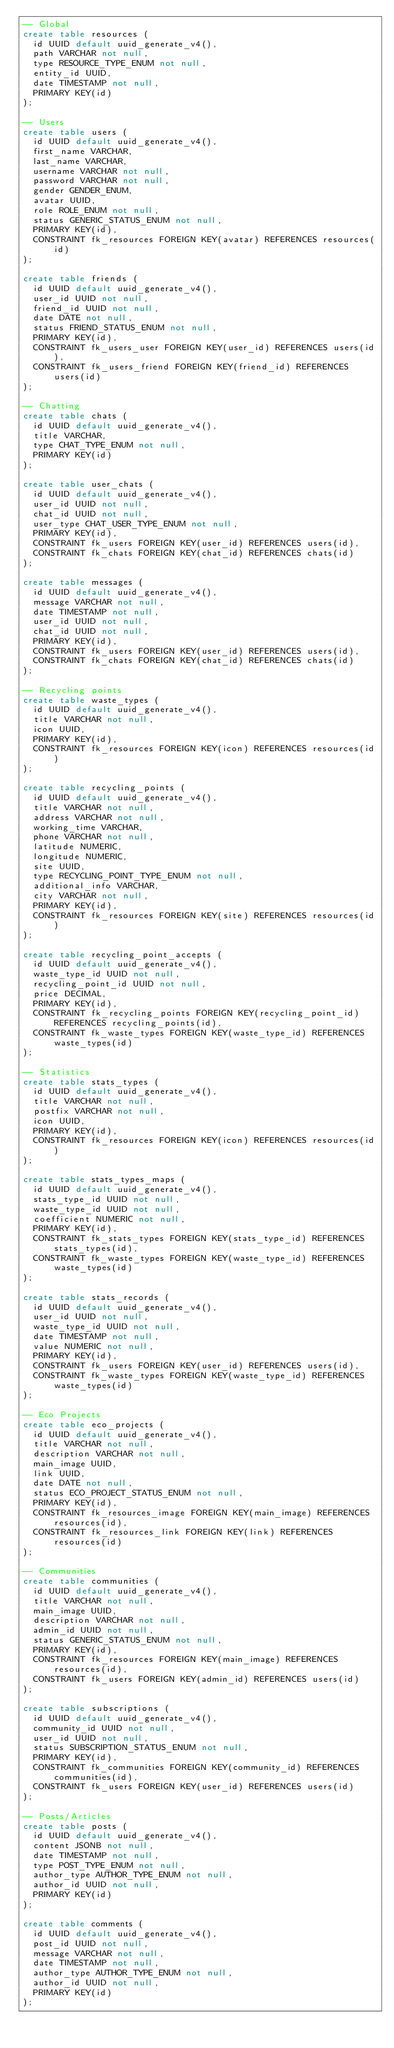<code> <loc_0><loc_0><loc_500><loc_500><_SQL_>-- Global
create table resources (
  id UUID default uuid_generate_v4(),
  path VARCHAR not null,
  type RESOURCE_TYPE_ENUM not null,
  entity_id UUID,
  date TIMESTAMP not null,
  PRIMARY KEY(id)
);

-- Users
create table users (
  id UUID default uuid_generate_v4(),
  first_name VARCHAR,
  last_name VARCHAR,
  username VARCHAR not null,
  password VARCHAR not null,
  gender GENDER_ENUM,
  avatar UUID,
  role ROLE_ENUM not null,
  status GENERIC_STATUS_ENUM not null,
  PRIMARY KEY(id),
  CONSTRAINT fk_resources FOREIGN KEY(avatar) REFERENCES resources(id)
);

create table friends (
  id UUID default uuid_generate_v4(),
  user_id UUID not null,
  friend_id UUID not null,
  date DATE not null,
  status FRIEND_STATUS_ENUM not null,
  PRIMARY KEY(id),
  CONSTRAINT fk_users_user FOREIGN KEY(user_id) REFERENCES users(id),
  CONSTRAINT fk_users_friend FOREIGN KEY(friend_id) REFERENCES users(id)
);

-- Chatting
create table chats (
  id UUID default uuid_generate_v4(),
  title VARCHAR,
  type CHAT_TYPE_ENUM not null,
  PRIMARY KEY(id)
);

create table user_chats (
  id UUID default uuid_generate_v4(),
  user_id UUID not null,
  chat_id UUID not null,
  user_type CHAT_USER_TYPE_ENUM not null,
  PRIMARY KEY(id),
  CONSTRAINT fk_users FOREIGN KEY(user_id) REFERENCES users(id),
  CONSTRAINT fk_chats FOREIGN KEY(chat_id) REFERENCES chats(id)
);

create table messages (
  id UUID default uuid_generate_v4(),
  message VARCHAR not null,
  date TIMESTAMP not null,
  user_id UUID not null,
  chat_id UUID not null,
  PRIMARY KEY(id),
  CONSTRAINT fk_users FOREIGN KEY(user_id) REFERENCES users(id),
  CONSTRAINT fk_chats FOREIGN KEY(chat_id) REFERENCES chats(id)
);

-- Recycling points
create table waste_types (
  id UUID default uuid_generate_v4(),
  title VARCHAR not null,
  icon UUID,
  PRIMARY KEY(id),
  CONSTRAINT fk_resources FOREIGN KEY(icon) REFERENCES resources(id)
);

create table recycling_points (
  id UUID default uuid_generate_v4(),
  title VARCHAR not null,
  address VARCHAR not null,
  working_time VARCHAR,
  phone VARCHAR not null,
  latitude NUMERIC,
  longitude NUMERIC,
  site UUID,
  type RECYCLING_POINT_TYPE_ENUM not null,
  additional_info VARCHAR,
  city VARCHAR not null,
  PRIMARY KEY(id),
  CONSTRAINT fk_resources FOREIGN KEY(site) REFERENCES resources(id)
);

create table recycling_point_accepts (
  id UUID default uuid_generate_v4(),
  waste_type_id UUID not null,
  recycling_point_id UUID not null,
  price DECIMAL,
  PRIMARY KEY(id),
  CONSTRAINT fk_recycling_points FOREIGN KEY(recycling_point_id) REFERENCES recycling_points(id),
  CONSTRAINT fk_waste_types FOREIGN KEY(waste_type_id) REFERENCES waste_types(id)
);

-- Statistics
create table stats_types (
  id UUID default uuid_generate_v4(),
  title VARCHAR not null,
  postfix VARCHAR not null,
  icon UUID,
  PRIMARY KEY(id),
  CONSTRAINT fk_resources FOREIGN KEY(icon) REFERENCES resources(id)
);

create table stats_types_maps (
  id UUID default uuid_generate_v4(),
  stats_type_id UUID not null,
  waste_type_id UUID not null,
  coefficient NUMERIC not null,
  PRIMARY KEY(id),
  CONSTRAINT fk_stats_types FOREIGN KEY(stats_type_id) REFERENCES stats_types(id),
  CONSTRAINT fk_waste_types FOREIGN KEY(waste_type_id) REFERENCES waste_types(id)
);

create table stats_records (
  id UUID default uuid_generate_v4(),
  user_id UUID not null,
  waste_type_id UUID not null,
  date TIMESTAMP not null,
  value NUMERIC not null,
  PRIMARY KEY(id),
  CONSTRAINT fk_users FOREIGN KEY(user_id) REFERENCES users(id),
  CONSTRAINT fk_waste_types FOREIGN KEY(waste_type_id) REFERENCES waste_types(id)
);

-- Eco Projects
create table eco_projects (
  id UUID default uuid_generate_v4(),
  title VARCHAR not null,
  description VARCHAR not null,
  main_image UUID,
  link UUID,
  date DATE not null,
  status ECO_PROJECT_STATUS_ENUM not null,
  PRIMARY KEY(id),
  CONSTRAINT fk_resources_image FOREIGN KEY(main_image) REFERENCES resources(id),
  CONSTRAINT fk_resources_link FOREIGN KEY(link) REFERENCES resources(id)
);

-- Communities
create table communities (
  id UUID default uuid_generate_v4(),
  title VARCHAR not null,
  main_image UUID,
  description VARCHAR not null,
  admin_id UUID not null,
  status GENERIC_STATUS_ENUM not null,
  PRIMARY KEY(id),
  CONSTRAINT fk_resources FOREIGN KEY(main_image) REFERENCES resources(id),
  CONSTRAINT fk_users FOREIGN KEY(admin_id) REFERENCES users(id)
);

create table subscriptions (
  id UUID default uuid_generate_v4(),
  community_id UUID not null,
  user_id UUID not null,
  status SUBSCRIPTION_STATUS_ENUM not null,
  PRIMARY KEY(id),
  CONSTRAINT fk_communities FOREIGN KEY(community_id) REFERENCES communities(id),
  CONSTRAINT fk_users FOREIGN KEY(user_id) REFERENCES users(id)
);

-- Posts/Articles
create table posts (
  id UUID default uuid_generate_v4(),
  content JSONB not null,
  date TIMESTAMP not null,
  type POST_TYPE_ENUM not null,
  author_type AUTHOR_TYPE_ENUM not null,
  author_id UUID not null,
  PRIMARY KEY(id)
);

create table comments (
  id UUID default uuid_generate_v4(),
  post_id UUID not null,
  message VARCHAR not null,
  date TIMESTAMP not null,
  author_type AUTHOR_TYPE_ENUM not null,
  author_id UUID not null,
  PRIMARY KEY(id)
);</code> 